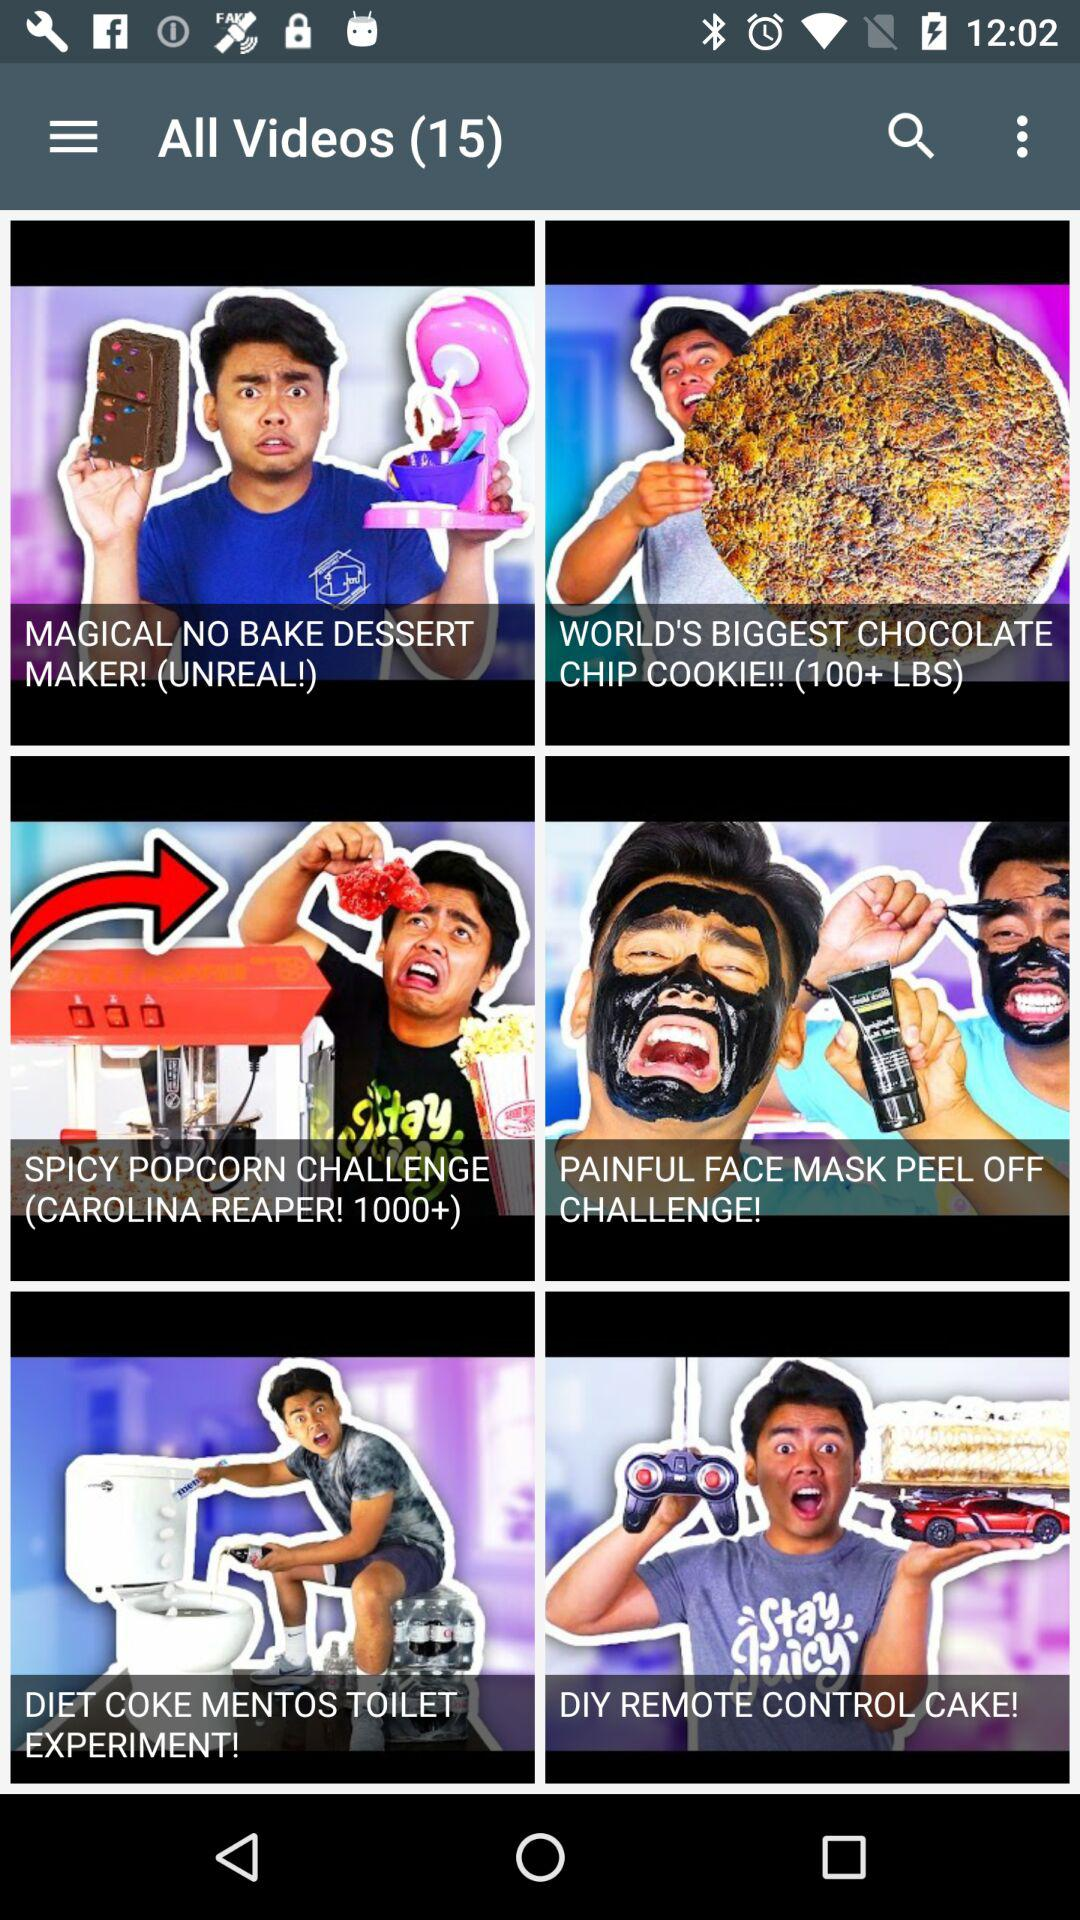How many videos are there in total? There are 15 videos in total. 